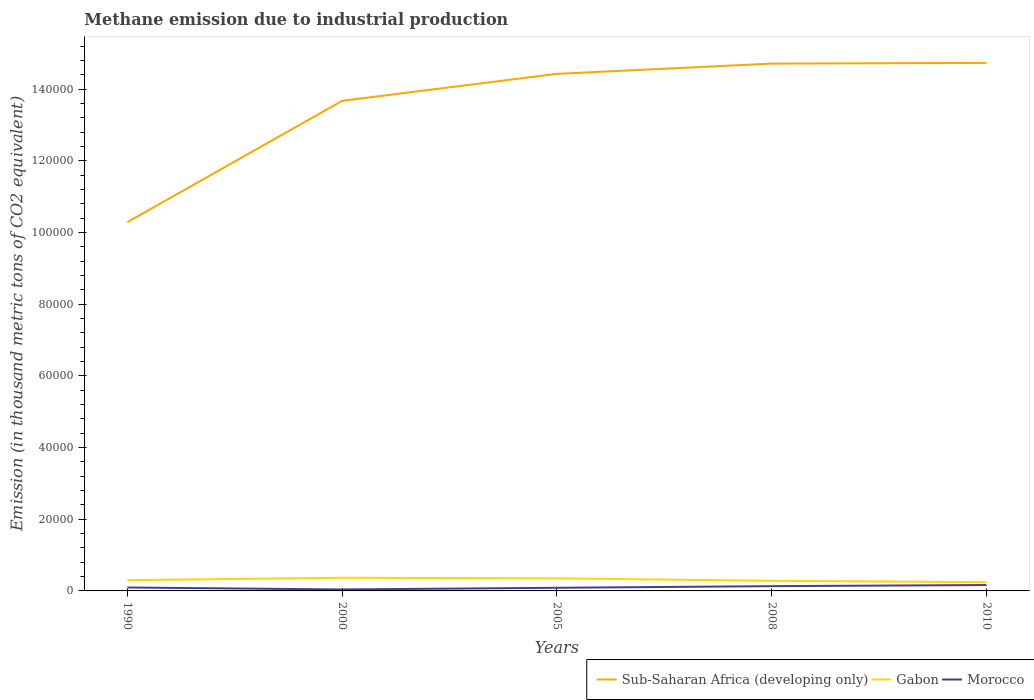Does the line corresponding to Morocco intersect with the line corresponding to Sub-Saharan Africa (developing only)?
Ensure brevity in your answer.  No. Across all years, what is the maximum amount of methane emitted in Gabon?
Give a very brief answer. 2434.4. In which year was the amount of methane emitted in Morocco maximum?
Make the answer very short. 2000. What is the total amount of methane emitted in Gabon in the graph?
Offer a very short reply. 393.6. What is the difference between the highest and the second highest amount of methane emitted in Sub-Saharan Africa (developing only)?
Offer a very short reply. 4.44e+04. Is the amount of methane emitted in Gabon strictly greater than the amount of methane emitted in Sub-Saharan Africa (developing only) over the years?
Give a very brief answer. Yes. Are the values on the major ticks of Y-axis written in scientific E-notation?
Offer a terse response. No. Does the graph contain any zero values?
Offer a very short reply. No. Does the graph contain grids?
Offer a terse response. No. Where does the legend appear in the graph?
Provide a short and direct response. Bottom right. How many legend labels are there?
Offer a very short reply. 3. How are the legend labels stacked?
Make the answer very short. Horizontal. What is the title of the graph?
Offer a terse response. Methane emission due to industrial production. What is the label or title of the Y-axis?
Provide a succinct answer. Emission (in thousand metric tons of CO2 equivalent). What is the Emission (in thousand metric tons of CO2 equivalent) of Sub-Saharan Africa (developing only) in 1990?
Provide a short and direct response. 1.03e+05. What is the Emission (in thousand metric tons of CO2 equivalent) in Gabon in 1990?
Offer a terse response. 2998.2. What is the Emission (in thousand metric tons of CO2 equivalent) of Morocco in 1990?
Provide a short and direct response. 955.4. What is the Emission (in thousand metric tons of CO2 equivalent) of Sub-Saharan Africa (developing only) in 2000?
Offer a terse response. 1.37e+05. What is the Emission (in thousand metric tons of CO2 equivalent) in Gabon in 2000?
Provide a short and direct response. 3670.7. What is the Emission (in thousand metric tons of CO2 equivalent) in Morocco in 2000?
Offer a terse response. 407.6. What is the Emission (in thousand metric tons of CO2 equivalent) in Sub-Saharan Africa (developing only) in 2005?
Ensure brevity in your answer.  1.44e+05. What is the Emission (in thousand metric tons of CO2 equivalent) in Gabon in 2005?
Your answer should be very brief. 3504.5. What is the Emission (in thousand metric tons of CO2 equivalent) of Morocco in 2005?
Keep it short and to the point. 877.7. What is the Emission (in thousand metric tons of CO2 equivalent) of Sub-Saharan Africa (developing only) in 2008?
Give a very brief answer. 1.47e+05. What is the Emission (in thousand metric tons of CO2 equivalent) in Gabon in 2008?
Offer a very short reply. 2828. What is the Emission (in thousand metric tons of CO2 equivalent) in Morocco in 2008?
Provide a succinct answer. 1328.7. What is the Emission (in thousand metric tons of CO2 equivalent) in Sub-Saharan Africa (developing only) in 2010?
Your answer should be compact. 1.47e+05. What is the Emission (in thousand metric tons of CO2 equivalent) of Gabon in 2010?
Offer a very short reply. 2434.4. What is the Emission (in thousand metric tons of CO2 equivalent) in Morocco in 2010?
Offer a very short reply. 1641.9. Across all years, what is the maximum Emission (in thousand metric tons of CO2 equivalent) of Sub-Saharan Africa (developing only)?
Offer a very short reply. 1.47e+05. Across all years, what is the maximum Emission (in thousand metric tons of CO2 equivalent) of Gabon?
Make the answer very short. 3670.7. Across all years, what is the maximum Emission (in thousand metric tons of CO2 equivalent) in Morocco?
Offer a very short reply. 1641.9. Across all years, what is the minimum Emission (in thousand metric tons of CO2 equivalent) of Sub-Saharan Africa (developing only)?
Keep it short and to the point. 1.03e+05. Across all years, what is the minimum Emission (in thousand metric tons of CO2 equivalent) of Gabon?
Offer a very short reply. 2434.4. Across all years, what is the minimum Emission (in thousand metric tons of CO2 equivalent) of Morocco?
Your answer should be compact. 407.6. What is the total Emission (in thousand metric tons of CO2 equivalent) in Sub-Saharan Africa (developing only) in the graph?
Ensure brevity in your answer.  6.78e+05. What is the total Emission (in thousand metric tons of CO2 equivalent) of Gabon in the graph?
Ensure brevity in your answer.  1.54e+04. What is the total Emission (in thousand metric tons of CO2 equivalent) in Morocco in the graph?
Your answer should be compact. 5211.3. What is the difference between the Emission (in thousand metric tons of CO2 equivalent) in Sub-Saharan Africa (developing only) in 1990 and that in 2000?
Provide a short and direct response. -3.38e+04. What is the difference between the Emission (in thousand metric tons of CO2 equivalent) in Gabon in 1990 and that in 2000?
Give a very brief answer. -672.5. What is the difference between the Emission (in thousand metric tons of CO2 equivalent) in Morocco in 1990 and that in 2000?
Ensure brevity in your answer.  547.8. What is the difference between the Emission (in thousand metric tons of CO2 equivalent) in Sub-Saharan Africa (developing only) in 1990 and that in 2005?
Ensure brevity in your answer.  -4.14e+04. What is the difference between the Emission (in thousand metric tons of CO2 equivalent) in Gabon in 1990 and that in 2005?
Your answer should be compact. -506.3. What is the difference between the Emission (in thousand metric tons of CO2 equivalent) in Morocco in 1990 and that in 2005?
Offer a very short reply. 77.7. What is the difference between the Emission (in thousand metric tons of CO2 equivalent) in Sub-Saharan Africa (developing only) in 1990 and that in 2008?
Provide a short and direct response. -4.42e+04. What is the difference between the Emission (in thousand metric tons of CO2 equivalent) in Gabon in 1990 and that in 2008?
Provide a succinct answer. 170.2. What is the difference between the Emission (in thousand metric tons of CO2 equivalent) of Morocco in 1990 and that in 2008?
Ensure brevity in your answer.  -373.3. What is the difference between the Emission (in thousand metric tons of CO2 equivalent) of Sub-Saharan Africa (developing only) in 1990 and that in 2010?
Give a very brief answer. -4.44e+04. What is the difference between the Emission (in thousand metric tons of CO2 equivalent) in Gabon in 1990 and that in 2010?
Your answer should be compact. 563.8. What is the difference between the Emission (in thousand metric tons of CO2 equivalent) of Morocco in 1990 and that in 2010?
Give a very brief answer. -686.5. What is the difference between the Emission (in thousand metric tons of CO2 equivalent) in Sub-Saharan Africa (developing only) in 2000 and that in 2005?
Your answer should be compact. -7528.2. What is the difference between the Emission (in thousand metric tons of CO2 equivalent) of Gabon in 2000 and that in 2005?
Make the answer very short. 166.2. What is the difference between the Emission (in thousand metric tons of CO2 equivalent) in Morocco in 2000 and that in 2005?
Provide a short and direct response. -470.1. What is the difference between the Emission (in thousand metric tons of CO2 equivalent) of Sub-Saharan Africa (developing only) in 2000 and that in 2008?
Offer a very short reply. -1.04e+04. What is the difference between the Emission (in thousand metric tons of CO2 equivalent) in Gabon in 2000 and that in 2008?
Your response must be concise. 842.7. What is the difference between the Emission (in thousand metric tons of CO2 equivalent) of Morocco in 2000 and that in 2008?
Keep it short and to the point. -921.1. What is the difference between the Emission (in thousand metric tons of CO2 equivalent) of Sub-Saharan Africa (developing only) in 2000 and that in 2010?
Your answer should be very brief. -1.06e+04. What is the difference between the Emission (in thousand metric tons of CO2 equivalent) of Gabon in 2000 and that in 2010?
Make the answer very short. 1236.3. What is the difference between the Emission (in thousand metric tons of CO2 equivalent) of Morocco in 2000 and that in 2010?
Your answer should be very brief. -1234.3. What is the difference between the Emission (in thousand metric tons of CO2 equivalent) in Sub-Saharan Africa (developing only) in 2005 and that in 2008?
Offer a terse response. -2859.6. What is the difference between the Emission (in thousand metric tons of CO2 equivalent) in Gabon in 2005 and that in 2008?
Provide a short and direct response. 676.5. What is the difference between the Emission (in thousand metric tons of CO2 equivalent) of Morocco in 2005 and that in 2008?
Offer a very short reply. -451. What is the difference between the Emission (in thousand metric tons of CO2 equivalent) of Sub-Saharan Africa (developing only) in 2005 and that in 2010?
Provide a succinct answer. -3051.9. What is the difference between the Emission (in thousand metric tons of CO2 equivalent) of Gabon in 2005 and that in 2010?
Offer a very short reply. 1070.1. What is the difference between the Emission (in thousand metric tons of CO2 equivalent) in Morocco in 2005 and that in 2010?
Your answer should be compact. -764.2. What is the difference between the Emission (in thousand metric tons of CO2 equivalent) in Sub-Saharan Africa (developing only) in 2008 and that in 2010?
Your response must be concise. -192.3. What is the difference between the Emission (in thousand metric tons of CO2 equivalent) in Gabon in 2008 and that in 2010?
Offer a terse response. 393.6. What is the difference between the Emission (in thousand metric tons of CO2 equivalent) of Morocco in 2008 and that in 2010?
Keep it short and to the point. -313.2. What is the difference between the Emission (in thousand metric tons of CO2 equivalent) in Sub-Saharan Africa (developing only) in 1990 and the Emission (in thousand metric tons of CO2 equivalent) in Gabon in 2000?
Provide a short and direct response. 9.92e+04. What is the difference between the Emission (in thousand metric tons of CO2 equivalent) of Sub-Saharan Africa (developing only) in 1990 and the Emission (in thousand metric tons of CO2 equivalent) of Morocco in 2000?
Ensure brevity in your answer.  1.02e+05. What is the difference between the Emission (in thousand metric tons of CO2 equivalent) in Gabon in 1990 and the Emission (in thousand metric tons of CO2 equivalent) in Morocco in 2000?
Keep it short and to the point. 2590.6. What is the difference between the Emission (in thousand metric tons of CO2 equivalent) in Sub-Saharan Africa (developing only) in 1990 and the Emission (in thousand metric tons of CO2 equivalent) in Gabon in 2005?
Ensure brevity in your answer.  9.94e+04. What is the difference between the Emission (in thousand metric tons of CO2 equivalent) of Sub-Saharan Africa (developing only) in 1990 and the Emission (in thousand metric tons of CO2 equivalent) of Morocco in 2005?
Ensure brevity in your answer.  1.02e+05. What is the difference between the Emission (in thousand metric tons of CO2 equivalent) in Gabon in 1990 and the Emission (in thousand metric tons of CO2 equivalent) in Morocco in 2005?
Ensure brevity in your answer.  2120.5. What is the difference between the Emission (in thousand metric tons of CO2 equivalent) in Sub-Saharan Africa (developing only) in 1990 and the Emission (in thousand metric tons of CO2 equivalent) in Gabon in 2008?
Your answer should be very brief. 1.00e+05. What is the difference between the Emission (in thousand metric tons of CO2 equivalent) of Sub-Saharan Africa (developing only) in 1990 and the Emission (in thousand metric tons of CO2 equivalent) of Morocco in 2008?
Keep it short and to the point. 1.02e+05. What is the difference between the Emission (in thousand metric tons of CO2 equivalent) of Gabon in 1990 and the Emission (in thousand metric tons of CO2 equivalent) of Morocco in 2008?
Offer a very short reply. 1669.5. What is the difference between the Emission (in thousand metric tons of CO2 equivalent) of Sub-Saharan Africa (developing only) in 1990 and the Emission (in thousand metric tons of CO2 equivalent) of Gabon in 2010?
Make the answer very short. 1.00e+05. What is the difference between the Emission (in thousand metric tons of CO2 equivalent) in Sub-Saharan Africa (developing only) in 1990 and the Emission (in thousand metric tons of CO2 equivalent) in Morocco in 2010?
Offer a very short reply. 1.01e+05. What is the difference between the Emission (in thousand metric tons of CO2 equivalent) in Gabon in 1990 and the Emission (in thousand metric tons of CO2 equivalent) in Morocco in 2010?
Ensure brevity in your answer.  1356.3. What is the difference between the Emission (in thousand metric tons of CO2 equivalent) in Sub-Saharan Africa (developing only) in 2000 and the Emission (in thousand metric tons of CO2 equivalent) in Gabon in 2005?
Give a very brief answer. 1.33e+05. What is the difference between the Emission (in thousand metric tons of CO2 equivalent) in Sub-Saharan Africa (developing only) in 2000 and the Emission (in thousand metric tons of CO2 equivalent) in Morocco in 2005?
Your response must be concise. 1.36e+05. What is the difference between the Emission (in thousand metric tons of CO2 equivalent) in Gabon in 2000 and the Emission (in thousand metric tons of CO2 equivalent) in Morocco in 2005?
Your answer should be very brief. 2793. What is the difference between the Emission (in thousand metric tons of CO2 equivalent) in Sub-Saharan Africa (developing only) in 2000 and the Emission (in thousand metric tons of CO2 equivalent) in Gabon in 2008?
Your answer should be very brief. 1.34e+05. What is the difference between the Emission (in thousand metric tons of CO2 equivalent) of Sub-Saharan Africa (developing only) in 2000 and the Emission (in thousand metric tons of CO2 equivalent) of Morocco in 2008?
Give a very brief answer. 1.35e+05. What is the difference between the Emission (in thousand metric tons of CO2 equivalent) in Gabon in 2000 and the Emission (in thousand metric tons of CO2 equivalent) in Morocco in 2008?
Offer a terse response. 2342. What is the difference between the Emission (in thousand metric tons of CO2 equivalent) of Sub-Saharan Africa (developing only) in 2000 and the Emission (in thousand metric tons of CO2 equivalent) of Gabon in 2010?
Offer a very short reply. 1.34e+05. What is the difference between the Emission (in thousand metric tons of CO2 equivalent) in Sub-Saharan Africa (developing only) in 2000 and the Emission (in thousand metric tons of CO2 equivalent) in Morocco in 2010?
Offer a terse response. 1.35e+05. What is the difference between the Emission (in thousand metric tons of CO2 equivalent) of Gabon in 2000 and the Emission (in thousand metric tons of CO2 equivalent) of Morocco in 2010?
Provide a succinct answer. 2028.8. What is the difference between the Emission (in thousand metric tons of CO2 equivalent) in Sub-Saharan Africa (developing only) in 2005 and the Emission (in thousand metric tons of CO2 equivalent) in Gabon in 2008?
Give a very brief answer. 1.41e+05. What is the difference between the Emission (in thousand metric tons of CO2 equivalent) in Sub-Saharan Africa (developing only) in 2005 and the Emission (in thousand metric tons of CO2 equivalent) in Morocco in 2008?
Ensure brevity in your answer.  1.43e+05. What is the difference between the Emission (in thousand metric tons of CO2 equivalent) in Gabon in 2005 and the Emission (in thousand metric tons of CO2 equivalent) in Morocco in 2008?
Keep it short and to the point. 2175.8. What is the difference between the Emission (in thousand metric tons of CO2 equivalent) of Sub-Saharan Africa (developing only) in 2005 and the Emission (in thousand metric tons of CO2 equivalent) of Gabon in 2010?
Keep it short and to the point. 1.42e+05. What is the difference between the Emission (in thousand metric tons of CO2 equivalent) in Sub-Saharan Africa (developing only) in 2005 and the Emission (in thousand metric tons of CO2 equivalent) in Morocco in 2010?
Provide a succinct answer. 1.43e+05. What is the difference between the Emission (in thousand metric tons of CO2 equivalent) of Gabon in 2005 and the Emission (in thousand metric tons of CO2 equivalent) of Morocco in 2010?
Your answer should be compact. 1862.6. What is the difference between the Emission (in thousand metric tons of CO2 equivalent) in Sub-Saharan Africa (developing only) in 2008 and the Emission (in thousand metric tons of CO2 equivalent) in Gabon in 2010?
Keep it short and to the point. 1.45e+05. What is the difference between the Emission (in thousand metric tons of CO2 equivalent) of Sub-Saharan Africa (developing only) in 2008 and the Emission (in thousand metric tons of CO2 equivalent) of Morocco in 2010?
Ensure brevity in your answer.  1.45e+05. What is the difference between the Emission (in thousand metric tons of CO2 equivalent) of Gabon in 2008 and the Emission (in thousand metric tons of CO2 equivalent) of Morocco in 2010?
Your answer should be very brief. 1186.1. What is the average Emission (in thousand metric tons of CO2 equivalent) in Sub-Saharan Africa (developing only) per year?
Your response must be concise. 1.36e+05. What is the average Emission (in thousand metric tons of CO2 equivalent) of Gabon per year?
Provide a succinct answer. 3087.16. What is the average Emission (in thousand metric tons of CO2 equivalent) of Morocco per year?
Offer a terse response. 1042.26. In the year 1990, what is the difference between the Emission (in thousand metric tons of CO2 equivalent) of Sub-Saharan Africa (developing only) and Emission (in thousand metric tons of CO2 equivalent) of Gabon?
Give a very brief answer. 9.99e+04. In the year 1990, what is the difference between the Emission (in thousand metric tons of CO2 equivalent) of Sub-Saharan Africa (developing only) and Emission (in thousand metric tons of CO2 equivalent) of Morocco?
Your answer should be compact. 1.02e+05. In the year 1990, what is the difference between the Emission (in thousand metric tons of CO2 equivalent) of Gabon and Emission (in thousand metric tons of CO2 equivalent) of Morocco?
Offer a terse response. 2042.8. In the year 2000, what is the difference between the Emission (in thousand metric tons of CO2 equivalent) of Sub-Saharan Africa (developing only) and Emission (in thousand metric tons of CO2 equivalent) of Gabon?
Your answer should be very brief. 1.33e+05. In the year 2000, what is the difference between the Emission (in thousand metric tons of CO2 equivalent) of Sub-Saharan Africa (developing only) and Emission (in thousand metric tons of CO2 equivalent) of Morocco?
Provide a succinct answer. 1.36e+05. In the year 2000, what is the difference between the Emission (in thousand metric tons of CO2 equivalent) of Gabon and Emission (in thousand metric tons of CO2 equivalent) of Morocco?
Make the answer very short. 3263.1. In the year 2005, what is the difference between the Emission (in thousand metric tons of CO2 equivalent) of Sub-Saharan Africa (developing only) and Emission (in thousand metric tons of CO2 equivalent) of Gabon?
Make the answer very short. 1.41e+05. In the year 2005, what is the difference between the Emission (in thousand metric tons of CO2 equivalent) in Sub-Saharan Africa (developing only) and Emission (in thousand metric tons of CO2 equivalent) in Morocco?
Offer a very short reply. 1.43e+05. In the year 2005, what is the difference between the Emission (in thousand metric tons of CO2 equivalent) in Gabon and Emission (in thousand metric tons of CO2 equivalent) in Morocco?
Offer a terse response. 2626.8. In the year 2008, what is the difference between the Emission (in thousand metric tons of CO2 equivalent) in Sub-Saharan Africa (developing only) and Emission (in thousand metric tons of CO2 equivalent) in Gabon?
Your answer should be compact. 1.44e+05. In the year 2008, what is the difference between the Emission (in thousand metric tons of CO2 equivalent) of Sub-Saharan Africa (developing only) and Emission (in thousand metric tons of CO2 equivalent) of Morocco?
Keep it short and to the point. 1.46e+05. In the year 2008, what is the difference between the Emission (in thousand metric tons of CO2 equivalent) in Gabon and Emission (in thousand metric tons of CO2 equivalent) in Morocco?
Your answer should be compact. 1499.3. In the year 2010, what is the difference between the Emission (in thousand metric tons of CO2 equivalent) in Sub-Saharan Africa (developing only) and Emission (in thousand metric tons of CO2 equivalent) in Gabon?
Keep it short and to the point. 1.45e+05. In the year 2010, what is the difference between the Emission (in thousand metric tons of CO2 equivalent) of Sub-Saharan Africa (developing only) and Emission (in thousand metric tons of CO2 equivalent) of Morocco?
Ensure brevity in your answer.  1.46e+05. In the year 2010, what is the difference between the Emission (in thousand metric tons of CO2 equivalent) of Gabon and Emission (in thousand metric tons of CO2 equivalent) of Morocco?
Ensure brevity in your answer.  792.5. What is the ratio of the Emission (in thousand metric tons of CO2 equivalent) of Sub-Saharan Africa (developing only) in 1990 to that in 2000?
Your response must be concise. 0.75. What is the ratio of the Emission (in thousand metric tons of CO2 equivalent) of Gabon in 1990 to that in 2000?
Your answer should be very brief. 0.82. What is the ratio of the Emission (in thousand metric tons of CO2 equivalent) in Morocco in 1990 to that in 2000?
Make the answer very short. 2.34. What is the ratio of the Emission (in thousand metric tons of CO2 equivalent) of Sub-Saharan Africa (developing only) in 1990 to that in 2005?
Offer a terse response. 0.71. What is the ratio of the Emission (in thousand metric tons of CO2 equivalent) in Gabon in 1990 to that in 2005?
Offer a terse response. 0.86. What is the ratio of the Emission (in thousand metric tons of CO2 equivalent) of Morocco in 1990 to that in 2005?
Provide a short and direct response. 1.09. What is the ratio of the Emission (in thousand metric tons of CO2 equivalent) in Sub-Saharan Africa (developing only) in 1990 to that in 2008?
Offer a terse response. 0.7. What is the ratio of the Emission (in thousand metric tons of CO2 equivalent) of Gabon in 1990 to that in 2008?
Your answer should be very brief. 1.06. What is the ratio of the Emission (in thousand metric tons of CO2 equivalent) of Morocco in 1990 to that in 2008?
Ensure brevity in your answer.  0.72. What is the ratio of the Emission (in thousand metric tons of CO2 equivalent) of Sub-Saharan Africa (developing only) in 1990 to that in 2010?
Keep it short and to the point. 0.7. What is the ratio of the Emission (in thousand metric tons of CO2 equivalent) of Gabon in 1990 to that in 2010?
Keep it short and to the point. 1.23. What is the ratio of the Emission (in thousand metric tons of CO2 equivalent) of Morocco in 1990 to that in 2010?
Provide a succinct answer. 0.58. What is the ratio of the Emission (in thousand metric tons of CO2 equivalent) in Sub-Saharan Africa (developing only) in 2000 to that in 2005?
Provide a short and direct response. 0.95. What is the ratio of the Emission (in thousand metric tons of CO2 equivalent) of Gabon in 2000 to that in 2005?
Keep it short and to the point. 1.05. What is the ratio of the Emission (in thousand metric tons of CO2 equivalent) in Morocco in 2000 to that in 2005?
Give a very brief answer. 0.46. What is the ratio of the Emission (in thousand metric tons of CO2 equivalent) of Sub-Saharan Africa (developing only) in 2000 to that in 2008?
Keep it short and to the point. 0.93. What is the ratio of the Emission (in thousand metric tons of CO2 equivalent) of Gabon in 2000 to that in 2008?
Provide a succinct answer. 1.3. What is the ratio of the Emission (in thousand metric tons of CO2 equivalent) in Morocco in 2000 to that in 2008?
Your response must be concise. 0.31. What is the ratio of the Emission (in thousand metric tons of CO2 equivalent) of Sub-Saharan Africa (developing only) in 2000 to that in 2010?
Provide a short and direct response. 0.93. What is the ratio of the Emission (in thousand metric tons of CO2 equivalent) of Gabon in 2000 to that in 2010?
Your response must be concise. 1.51. What is the ratio of the Emission (in thousand metric tons of CO2 equivalent) in Morocco in 2000 to that in 2010?
Your response must be concise. 0.25. What is the ratio of the Emission (in thousand metric tons of CO2 equivalent) of Sub-Saharan Africa (developing only) in 2005 to that in 2008?
Provide a short and direct response. 0.98. What is the ratio of the Emission (in thousand metric tons of CO2 equivalent) of Gabon in 2005 to that in 2008?
Your response must be concise. 1.24. What is the ratio of the Emission (in thousand metric tons of CO2 equivalent) in Morocco in 2005 to that in 2008?
Your answer should be compact. 0.66. What is the ratio of the Emission (in thousand metric tons of CO2 equivalent) in Sub-Saharan Africa (developing only) in 2005 to that in 2010?
Offer a terse response. 0.98. What is the ratio of the Emission (in thousand metric tons of CO2 equivalent) in Gabon in 2005 to that in 2010?
Offer a very short reply. 1.44. What is the ratio of the Emission (in thousand metric tons of CO2 equivalent) of Morocco in 2005 to that in 2010?
Provide a succinct answer. 0.53. What is the ratio of the Emission (in thousand metric tons of CO2 equivalent) of Sub-Saharan Africa (developing only) in 2008 to that in 2010?
Your answer should be very brief. 1. What is the ratio of the Emission (in thousand metric tons of CO2 equivalent) in Gabon in 2008 to that in 2010?
Make the answer very short. 1.16. What is the ratio of the Emission (in thousand metric tons of CO2 equivalent) of Morocco in 2008 to that in 2010?
Ensure brevity in your answer.  0.81. What is the difference between the highest and the second highest Emission (in thousand metric tons of CO2 equivalent) in Sub-Saharan Africa (developing only)?
Your response must be concise. 192.3. What is the difference between the highest and the second highest Emission (in thousand metric tons of CO2 equivalent) in Gabon?
Your answer should be very brief. 166.2. What is the difference between the highest and the second highest Emission (in thousand metric tons of CO2 equivalent) in Morocco?
Give a very brief answer. 313.2. What is the difference between the highest and the lowest Emission (in thousand metric tons of CO2 equivalent) of Sub-Saharan Africa (developing only)?
Provide a short and direct response. 4.44e+04. What is the difference between the highest and the lowest Emission (in thousand metric tons of CO2 equivalent) in Gabon?
Give a very brief answer. 1236.3. What is the difference between the highest and the lowest Emission (in thousand metric tons of CO2 equivalent) in Morocco?
Your answer should be compact. 1234.3. 